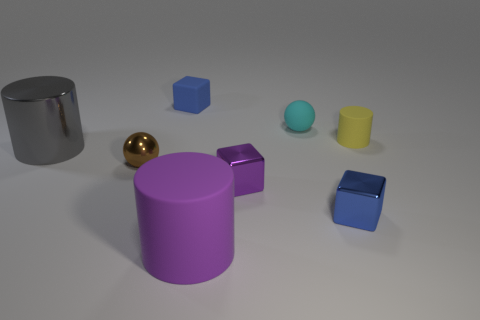Are there an equal number of cylinders in front of the metallic cylinder and cyan cylinders?
Offer a very short reply. No. There is a tiny blue object that is right of the tiny cyan thing; are there any large cylinders in front of it?
Offer a terse response. Yes. There is a sphere on the right side of the object that is in front of the blue block that is in front of the small matte cylinder; how big is it?
Your response must be concise. Small. What material is the large cylinder that is behind the tiny blue object in front of the big gray cylinder?
Give a very brief answer. Metal. Are there any small blue shiny objects that have the same shape as the purple metal object?
Give a very brief answer. Yes. What shape is the small brown shiny thing?
Provide a short and direct response. Sphere. What is the material of the purple thing behind the blue object in front of the matte cylinder that is right of the purple cylinder?
Keep it short and to the point. Metal. Are there more spheres right of the brown metal sphere than green cylinders?
Provide a succinct answer. Yes. There is another cylinder that is the same size as the metallic cylinder; what material is it?
Your answer should be compact. Rubber. Is there a brown metallic sphere that has the same size as the cyan matte object?
Your answer should be compact. Yes. 